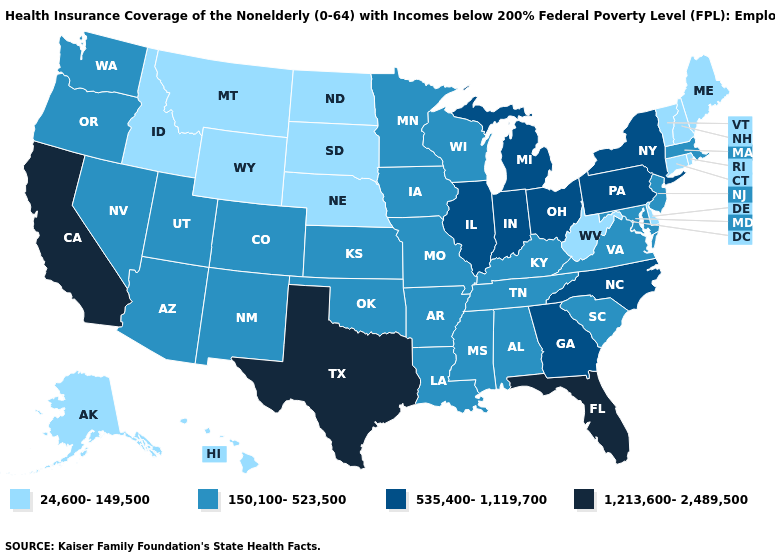What is the lowest value in the USA?
Keep it brief. 24,600-149,500. What is the highest value in the West ?
Keep it brief. 1,213,600-2,489,500. What is the value of Virginia?
Short answer required. 150,100-523,500. Name the states that have a value in the range 535,400-1,119,700?
Short answer required. Georgia, Illinois, Indiana, Michigan, New York, North Carolina, Ohio, Pennsylvania. Name the states that have a value in the range 24,600-149,500?
Give a very brief answer. Alaska, Connecticut, Delaware, Hawaii, Idaho, Maine, Montana, Nebraska, New Hampshire, North Dakota, Rhode Island, South Dakota, Vermont, West Virginia, Wyoming. What is the lowest value in the USA?
Give a very brief answer. 24,600-149,500. Does Ohio have a higher value than Texas?
Concise answer only. No. How many symbols are there in the legend?
Write a very short answer. 4. Which states have the highest value in the USA?
Answer briefly. California, Florida, Texas. Is the legend a continuous bar?
Short answer required. No. What is the lowest value in the USA?
Quick response, please. 24,600-149,500. Does Maine have the highest value in the Northeast?
Give a very brief answer. No. Which states have the highest value in the USA?
Give a very brief answer. California, Florida, Texas. Which states have the lowest value in the MidWest?
Be succinct. Nebraska, North Dakota, South Dakota. Among the states that border Maryland , does Virginia have the highest value?
Short answer required. No. 